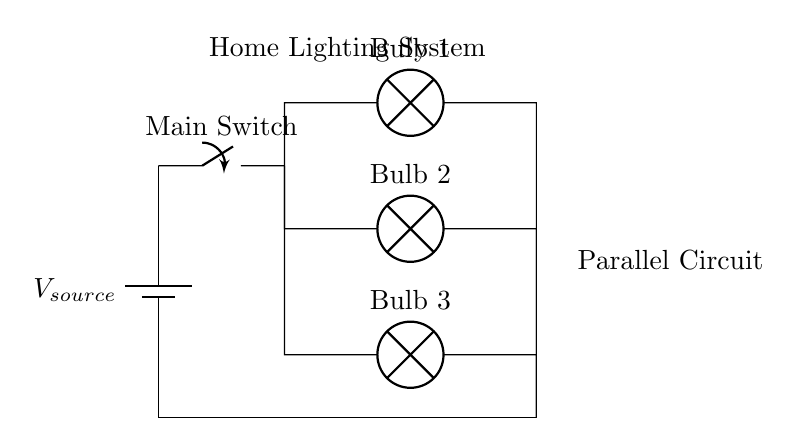What is the main power source in this circuit? The power source is indicated by the battery symbol, labeled as V source.
Answer: V source How many bulbs are connected in parallel? The diagram shows three distinct lamps connected in separate branches from the main circuit, confirming their parallel arrangement.
Answer: Three What function does the main switch serve? The main switch controls the flow of current in the entire circuit, allowing or preventing electricity from powering the bulbs when turned on or off.
Answer: Control If one bulb fails, what happens to the others? In a parallel circuit, each bulb operates independently. If one bulb fails or is removed, the other bulbs will continue to receive power and function normally.
Answer: They stay on What is the overall configuration of the circuit? The circuit is comprised of branches that connect at a common point, allowing the current to divide and flow through each bulb simultaneously, characteristic of a parallel configuration.
Answer: Parallel What is the voltage across each bulb? Each bulb in a parallel circuit receives the same voltage as supplied by the power source, typically ensuring consistent brightness across all bulbs.
Answer: Same as V source 